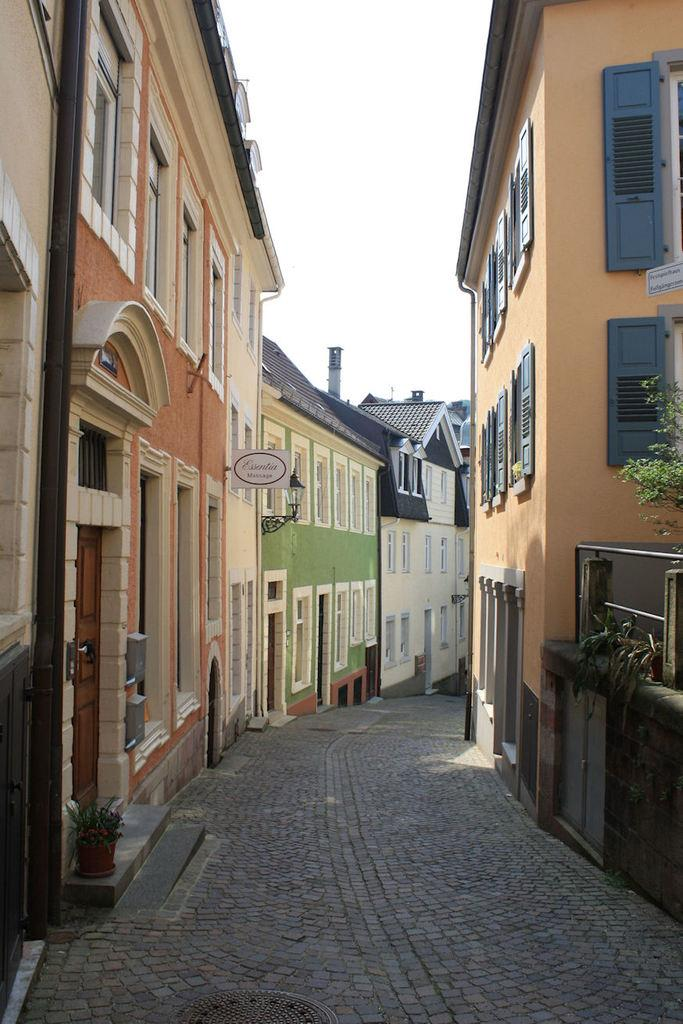What type of structures can be seen in the image? There are houses with windows in the image. What else can be seen on the ground in the image? There is a road in the image. Are there any plants visible in the image? Yes, there are plants in pots in the image. What is the background of the image? There is a wall in the image, and the sky is visible. Is there any written information in the image? Yes, there is some written text on a board in the image. Can you see a wrench being used near the plants in the image? No, there is no wrench visible in the image. Is there a lake in the background of the image? No, there is no lake present in the image. 